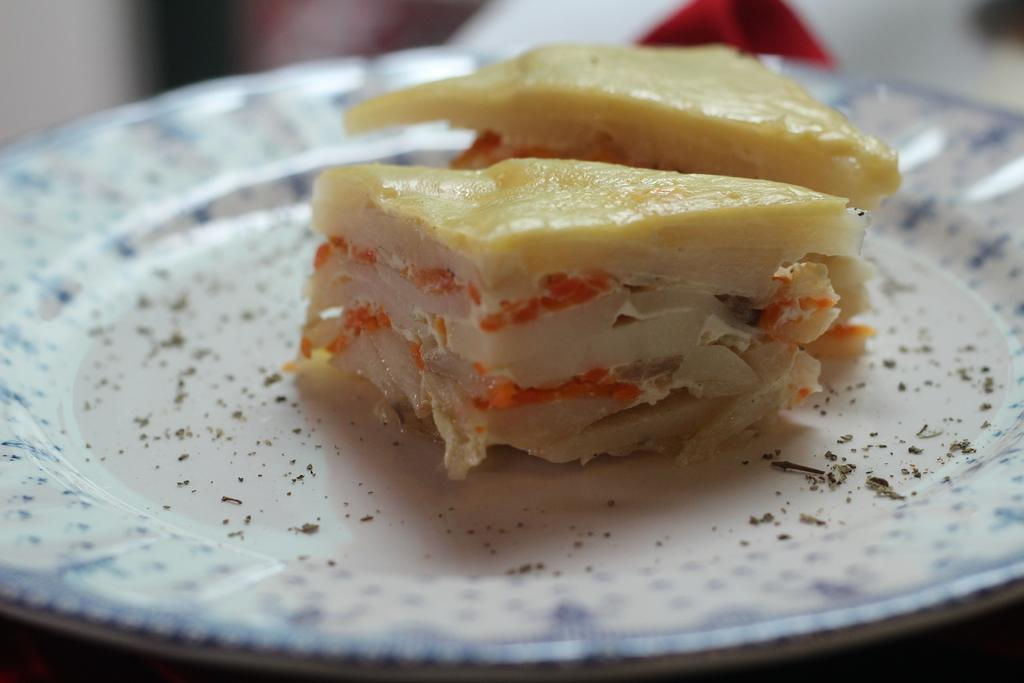What is the main subject of the image? There is a food item in the image. Where is the food item located? The food item is on a table. Can you describe the background of the image? The background of the image is slightly blurred. What type of destruction can be seen in the image? There is no destruction present in the image; it features a food item on a table with a slightly blurred background. 